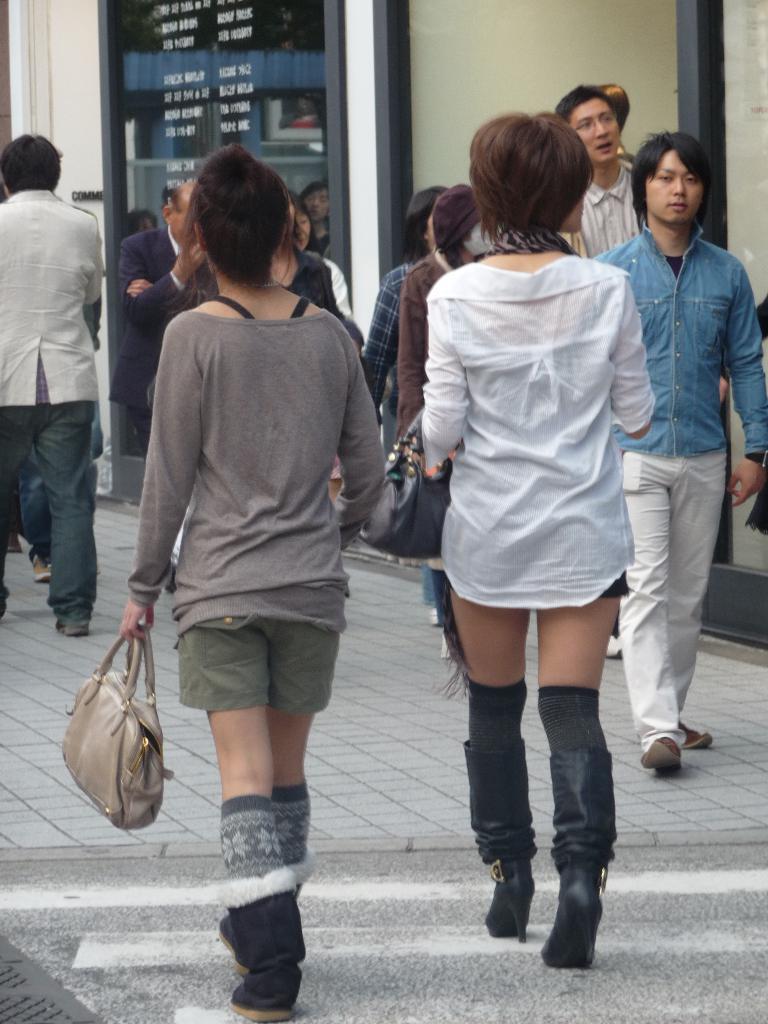Can you describe this image briefly? As we can see in the image there is a wall and few people walking on road. 